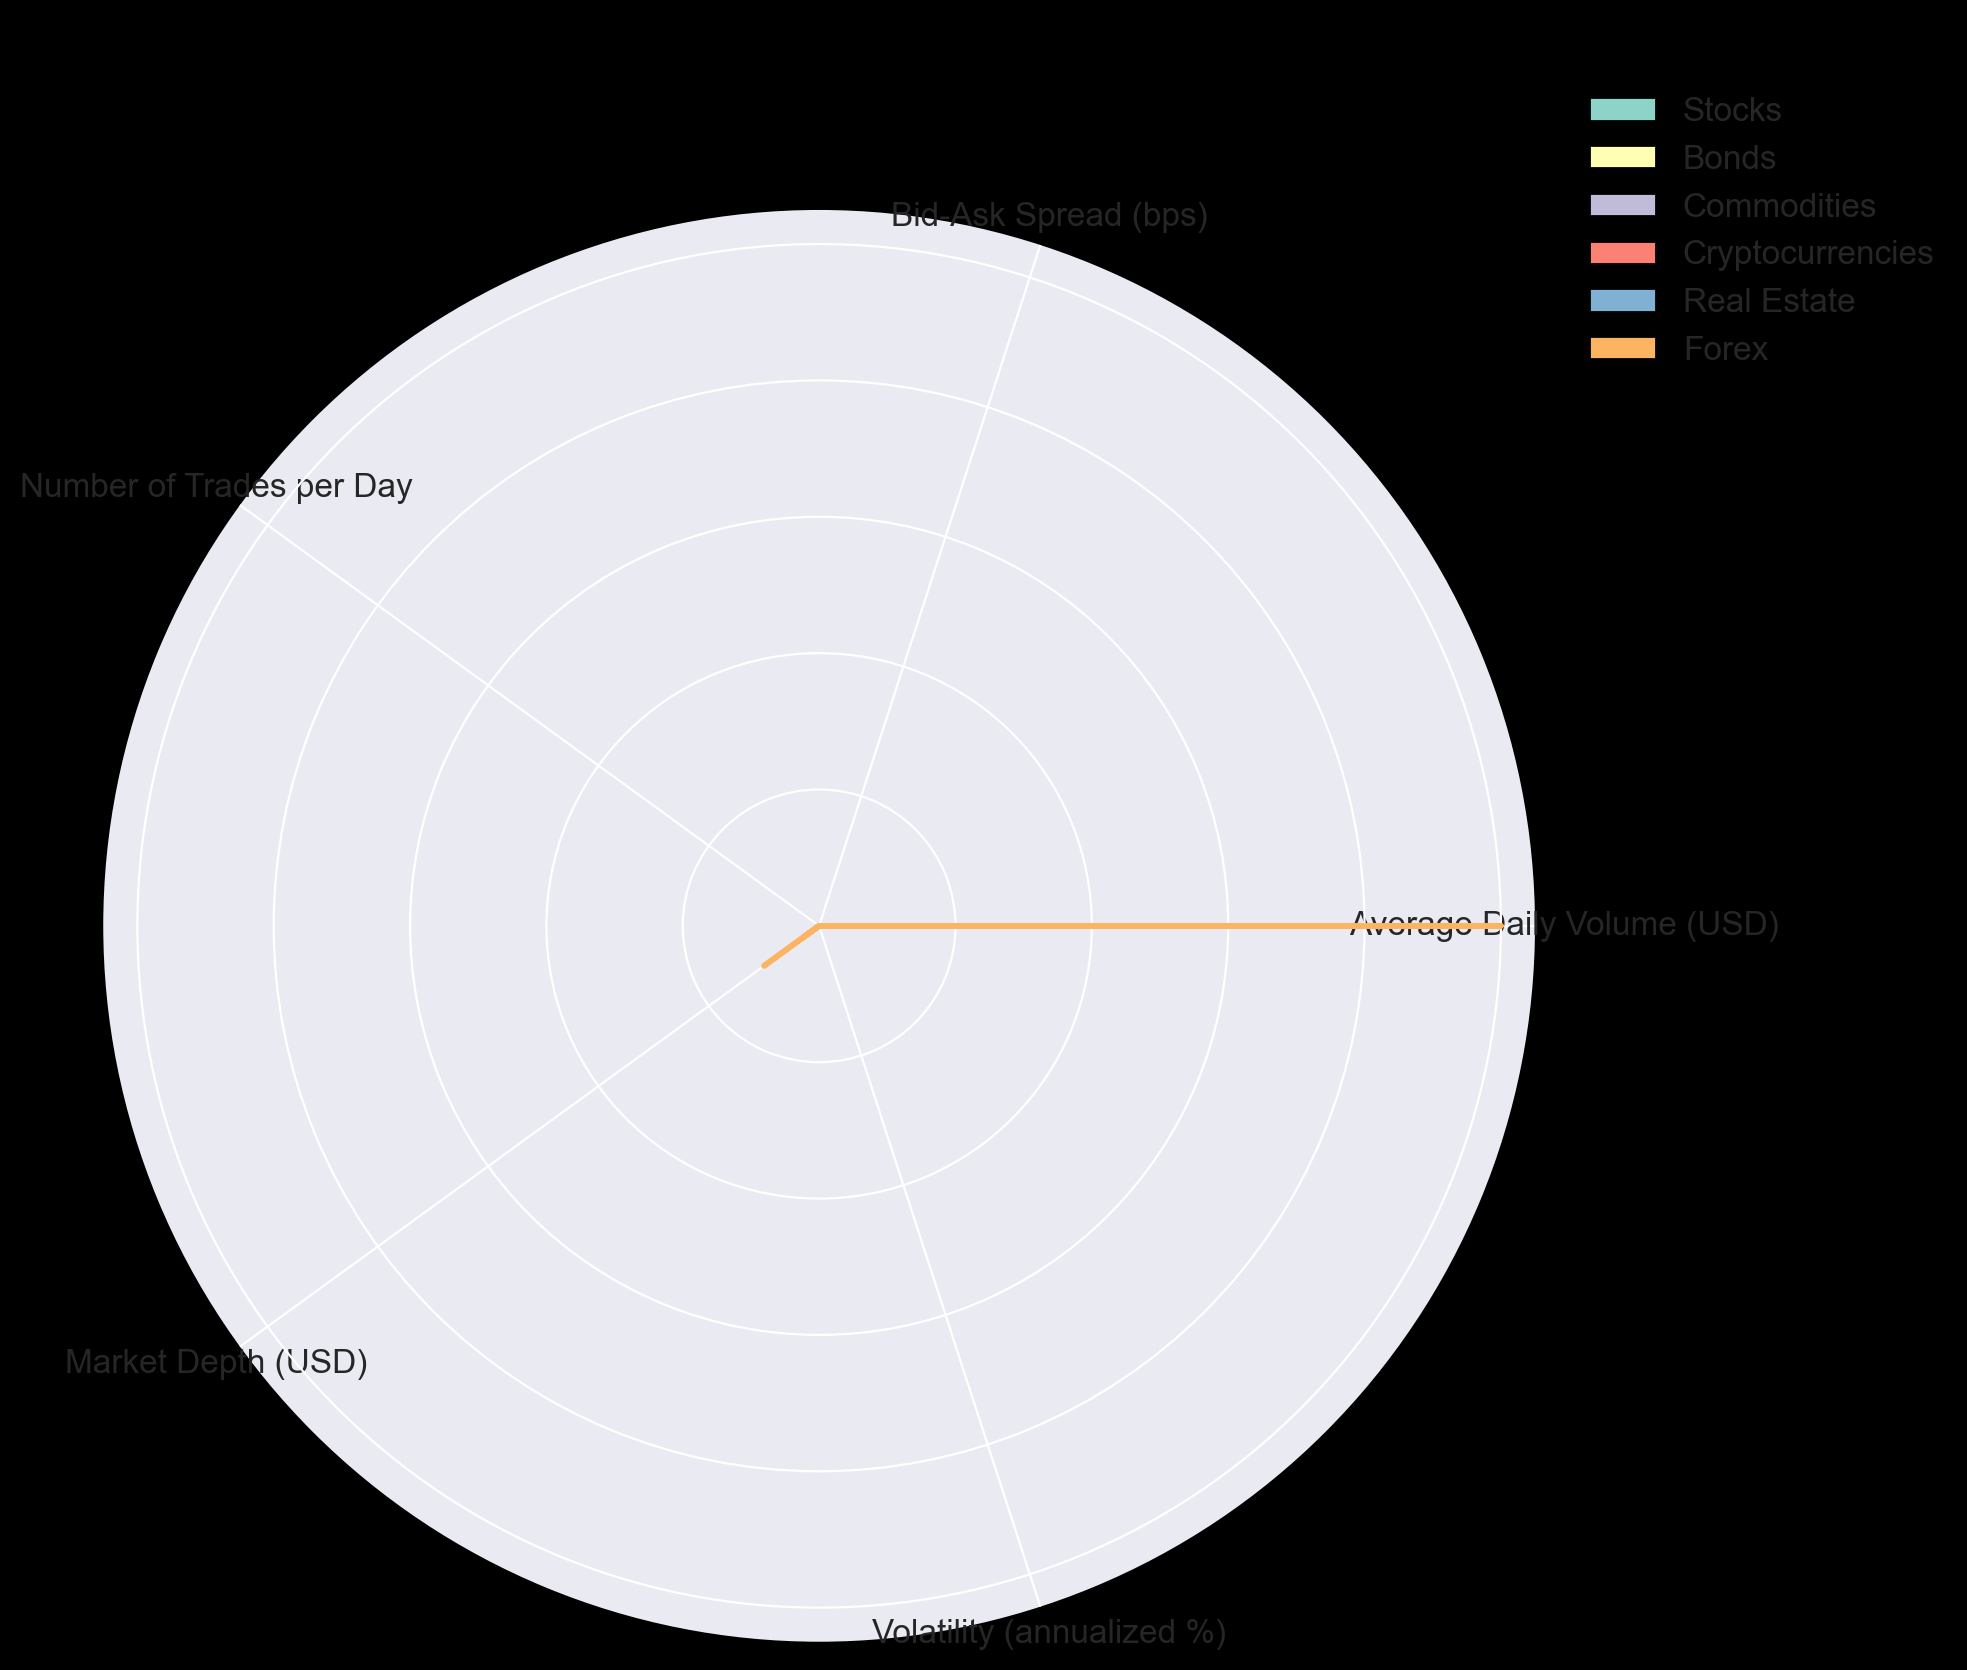What asset class shows the highest market depth? By examining the radar chart, market depth for each asset class is represented by one of the axes. The asset class with the longest stretch in the market depth direction will have the highest market depth. Forex has the farthest-reaching mark on the market depth axis.
Answer: Forex Which asset class has the smallest average daily volume? To find the smallest average daily volume, look for the shortest distance from the origin along the respective axis for average daily volume. Real Estate has the shortest marker on the average daily volume axis.
Answer: Real Estate How does the bid-ask spread of cryptocurrencies compare to that of stocks? Locate the bid-ask spread values for both stocks and cryptocurrencies on the respective axis. Cryptocurrencies are farther from the center compared to stocks on this axis, indicating a higher bid-ask spread.
Answer: Cryptocurrencies have a higher bid-ask spread than stocks Which two asset classes have similar volatility? Examine the distance from the center along the volatility axis for all asset classes. Commodities and Forex have similar distances from the center on this axis.
Answer: Commodities and Forex What is the combined number of trades per day for Bonds and Real Estate? Refer to the axis for the number of trades per day and sum the values for Bonds and Real Estate. Bonds have 3,000 trades per day, and Real Estate has 200 trades per day, leading to a sum of 3,200.
Answer: 3,200 Compare the volatility of cryptocurrencies and bonds. Which is higher? Check the distance from the center along the volatility axis for both cryptocurrencies and bonds. Cryptocurrencies are much farther from the center on this axis than bonds.
Answer: Cryptocurrencies have higher volatility than bonds Which asset class has the second-highest bid-ask spread, and how much is it? Find each asset class's distances from the center along the bid-ask spread axis. Identifying the second-highest value after the top (Real Estate), cryptocurrencies come next.
Answer: Cryptocurrencies, 30 bps What is the difference in market depth between Cryptocurrencies and Stocks? Identify the points for cryptocurrencies and stocks along the market depth axis and read their values. Cryptocurrencies have a market depth of $150,000,000, and stocks have $30,000,000. Subtract stocks from cryptocurrencies for the difference: $150,000,000 - $30,000,000 = $120,000,000.
Answer: $120,000,000 Which has a lower bid-ask spread, Forex or Commodities? Compare the lengths of Forex and Commodities along the bid-ask spread axis. Forex's mark is closer to the center than Commodities, indicating a lower bid-ask spread.
Answer: Forex How do the average daily volumes of Stocks and Forex compare? Observe both marks on the average daily volume axis. Forex is farther from the center on this axis than Stocks.
Answer: Forex has a higher average daily volume than Stocks 